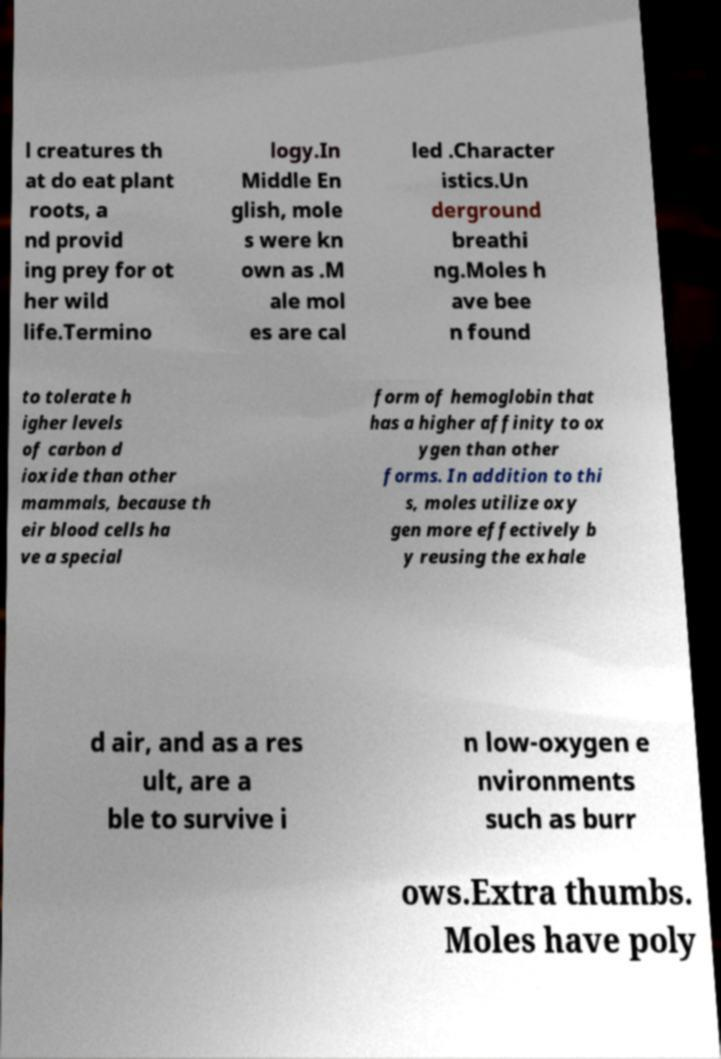What messages or text are displayed in this image? I need them in a readable, typed format. l creatures th at do eat plant roots, a nd provid ing prey for ot her wild life.Termino logy.In Middle En glish, mole s were kn own as .M ale mol es are cal led .Character istics.Un derground breathi ng.Moles h ave bee n found to tolerate h igher levels of carbon d ioxide than other mammals, because th eir blood cells ha ve a special form of hemoglobin that has a higher affinity to ox ygen than other forms. In addition to thi s, moles utilize oxy gen more effectively b y reusing the exhale d air, and as a res ult, are a ble to survive i n low-oxygen e nvironments such as burr ows.Extra thumbs. Moles have poly 